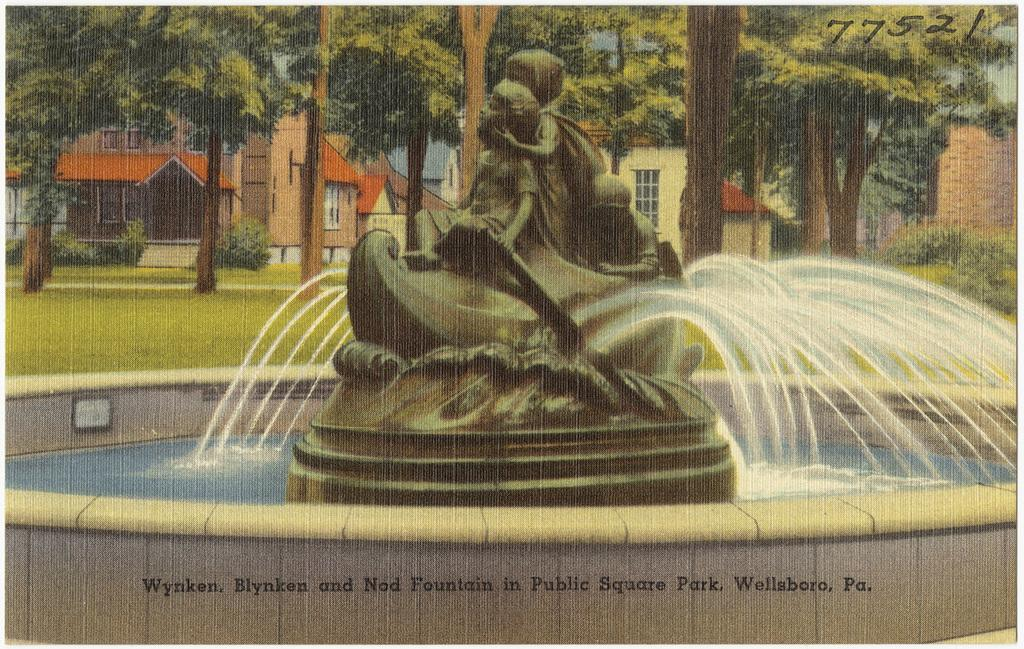What is the main feature in the image? There is a water fountain in the image. What is on top of the water fountain? The water fountain has a statue. What can be seen in the distance behind the water fountain? There are houses, plants, and trees in the background of the image. What are the houses in the background like? The houses have windows. Is there any text or marking at the bottom of the image? Yes, there is a watermark at the bottom of the image. What type of vegetable is growing near the water fountain in the image? There are no vegetables visible in the image; it features a water fountain with a statue and a background of houses, plants, and trees. 